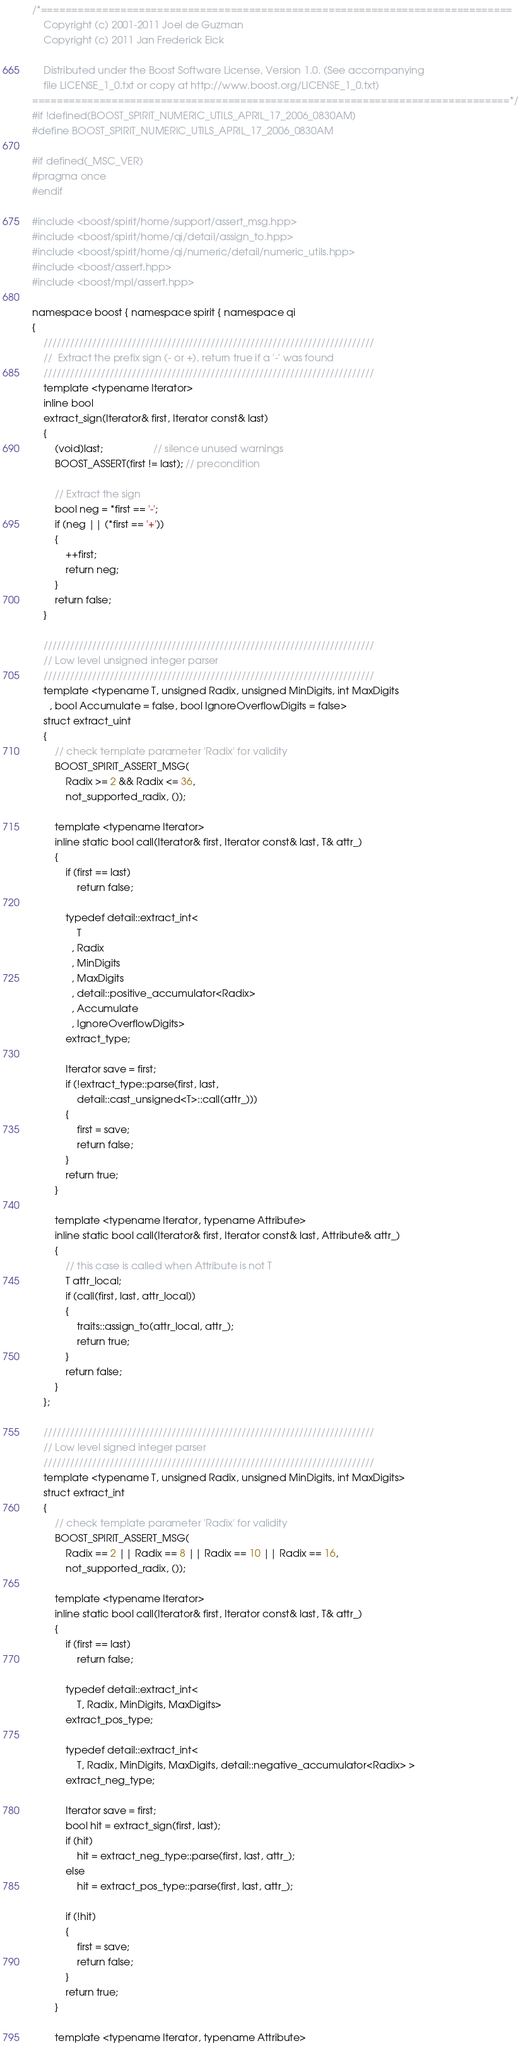Convert code to text. <code><loc_0><loc_0><loc_500><loc_500><_C++_>/*=============================================================================
    Copyright (c) 2001-2011 Joel de Guzman
    Copyright (c) 2011 Jan Frederick Eick

    Distributed under the Boost Software License, Version 1.0. (See accompanying
    file LICENSE_1_0.txt or copy at http://www.boost.org/LICENSE_1_0.txt)
==============================================================================*/
#if !defined(BOOST_SPIRIT_NUMERIC_UTILS_APRIL_17_2006_0830AM)
#define BOOST_SPIRIT_NUMERIC_UTILS_APRIL_17_2006_0830AM

#if defined(_MSC_VER)
#pragma once
#endif

#include <boost/spirit/home/support/assert_msg.hpp>
#include <boost/spirit/home/qi/detail/assign_to.hpp>
#include <boost/spirit/home/qi/numeric/detail/numeric_utils.hpp>
#include <boost/assert.hpp>
#include <boost/mpl/assert.hpp>

namespace boost { namespace spirit { namespace qi
{
    ///////////////////////////////////////////////////////////////////////////
    //  Extract the prefix sign (- or +), return true if a '-' was found
    ///////////////////////////////////////////////////////////////////////////
    template <typename Iterator>
    inline bool
    extract_sign(Iterator& first, Iterator const& last)
    {
        (void)last;                  // silence unused warnings
        BOOST_ASSERT(first != last); // precondition

        // Extract the sign
        bool neg = *first == '-';
        if (neg || (*first == '+'))
        {
            ++first;
            return neg;
        }
        return false;
    }

    ///////////////////////////////////////////////////////////////////////////
    // Low level unsigned integer parser
    ///////////////////////////////////////////////////////////////////////////
    template <typename T, unsigned Radix, unsigned MinDigits, int MaxDigits
      , bool Accumulate = false, bool IgnoreOverflowDigits = false>
    struct extract_uint
    {
        // check template parameter 'Radix' for validity
        BOOST_SPIRIT_ASSERT_MSG(
            Radix >= 2 && Radix <= 36,
            not_supported_radix, ());

        template <typename Iterator>
        inline static bool call(Iterator& first, Iterator const& last, T& attr_)
        {
            if (first == last)
                return false;

            typedef detail::extract_int<
                T
              , Radix
              , MinDigits
              , MaxDigits
              , detail::positive_accumulator<Radix>
              , Accumulate
              , IgnoreOverflowDigits>
            extract_type;

            Iterator save = first;
            if (!extract_type::parse(first, last,
                detail::cast_unsigned<T>::call(attr_)))
            {
                first = save;
                return false;
            }
            return true;
        }

        template <typename Iterator, typename Attribute>
        inline static bool call(Iterator& first, Iterator const& last, Attribute& attr_)
        {
            // this case is called when Attribute is not T
            T attr_local;
            if (call(first, last, attr_local))
            {
                traits::assign_to(attr_local, attr_);
                return true;
            }
            return false;
        }
    };

    ///////////////////////////////////////////////////////////////////////////
    // Low level signed integer parser
    ///////////////////////////////////////////////////////////////////////////
    template <typename T, unsigned Radix, unsigned MinDigits, int MaxDigits>
    struct extract_int
    {
        // check template parameter 'Radix' for validity
        BOOST_SPIRIT_ASSERT_MSG(
            Radix == 2 || Radix == 8 || Radix == 10 || Radix == 16,
            not_supported_radix, ());

        template <typename Iterator>
        inline static bool call(Iterator& first, Iterator const& last, T& attr_)
        {
            if (first == last)
                return false;

            typedef detail::extract_int<
                T, Radix, MinDigits, MaxDigits>
            extract_pos_type;

            typedef detail::extract_int<
                T, Radix, MinDigits, MaxDigits, detail::negative_accumulator<Radix> >
            extract_neg_type;

            Iterator save = first;
            bool hit = extract_sign(first, last);
            if (hit)
                hit = extract_neg_type::parse(first, last, attr_);
            else
                hit = extract_pos_type::parse(first, last, attr_);

            if (!hit)
            {
                first = save;
                return false;
            }
            return true;
        }

        template <typename Iterator, typename Attribute></code> 